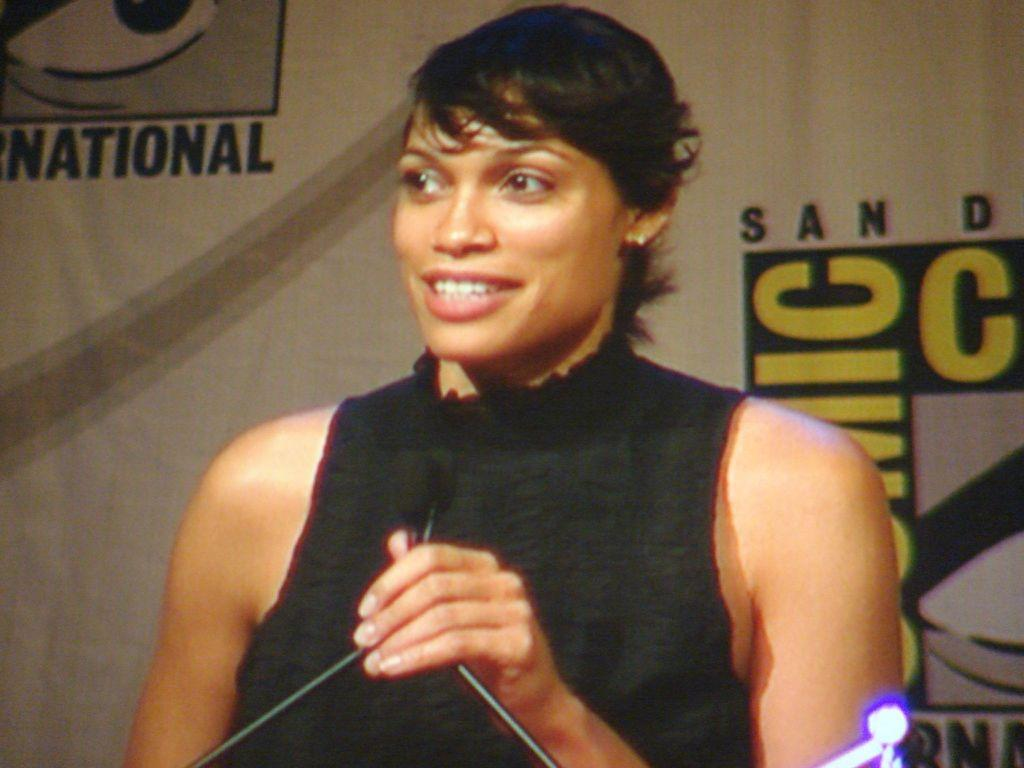Who is the main subject in the image? There is a woman in the image. What is the woman doing in the image? The woman is smiling. What object is in front of the woman? There is a microphone in front of the woman. What can be seen in the background of the image? There is text visible in the background of the image. What type of calculator is the woman using in the image? There is no calculator present in the image. 